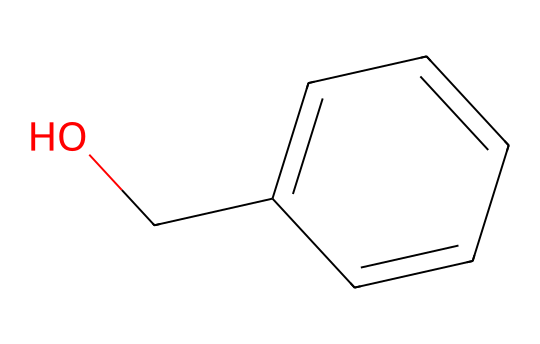What is the molecular formula of benzyl alcohol? The SMILES representation OCc1ccccc1 indicates that the structure contains one hydroxyl group (OH) and a benzene ring (C6H5). Counting the carbon atoms and considering the hydroxyl group, we find the formula is C7H8O.
Answer: C7H8O How many carbon atoms are present in benzyl alcohol? Analyzing the SMILES representation, there are a total of seven carbon atoms: one from the hydroxyl group and six in the aromatic ring.
Answer: 7 What functional group is present in benzyl alcohol? The presence of the –OH group in the SMILES representation indicates that benzyl alcohol contains a hydroxyl functional group, which characterizes it as an alcohol.
Answer: hydroxyl How many rings are in the structure of benzyl alcohol? By examining the benzene structure denoted by "c1ccccc1" in the SMILES, we determine that there is one ring in benzyl alcohol.
Answer: 1 Why is benzyl alcohol used as a preservative? Benzyl alcohol is an effective preservative because it has antimicrobial properties, preventing the growth of bacteria and fungi, which is beneficial in personal care products.
Answer: antimicrobial properties 